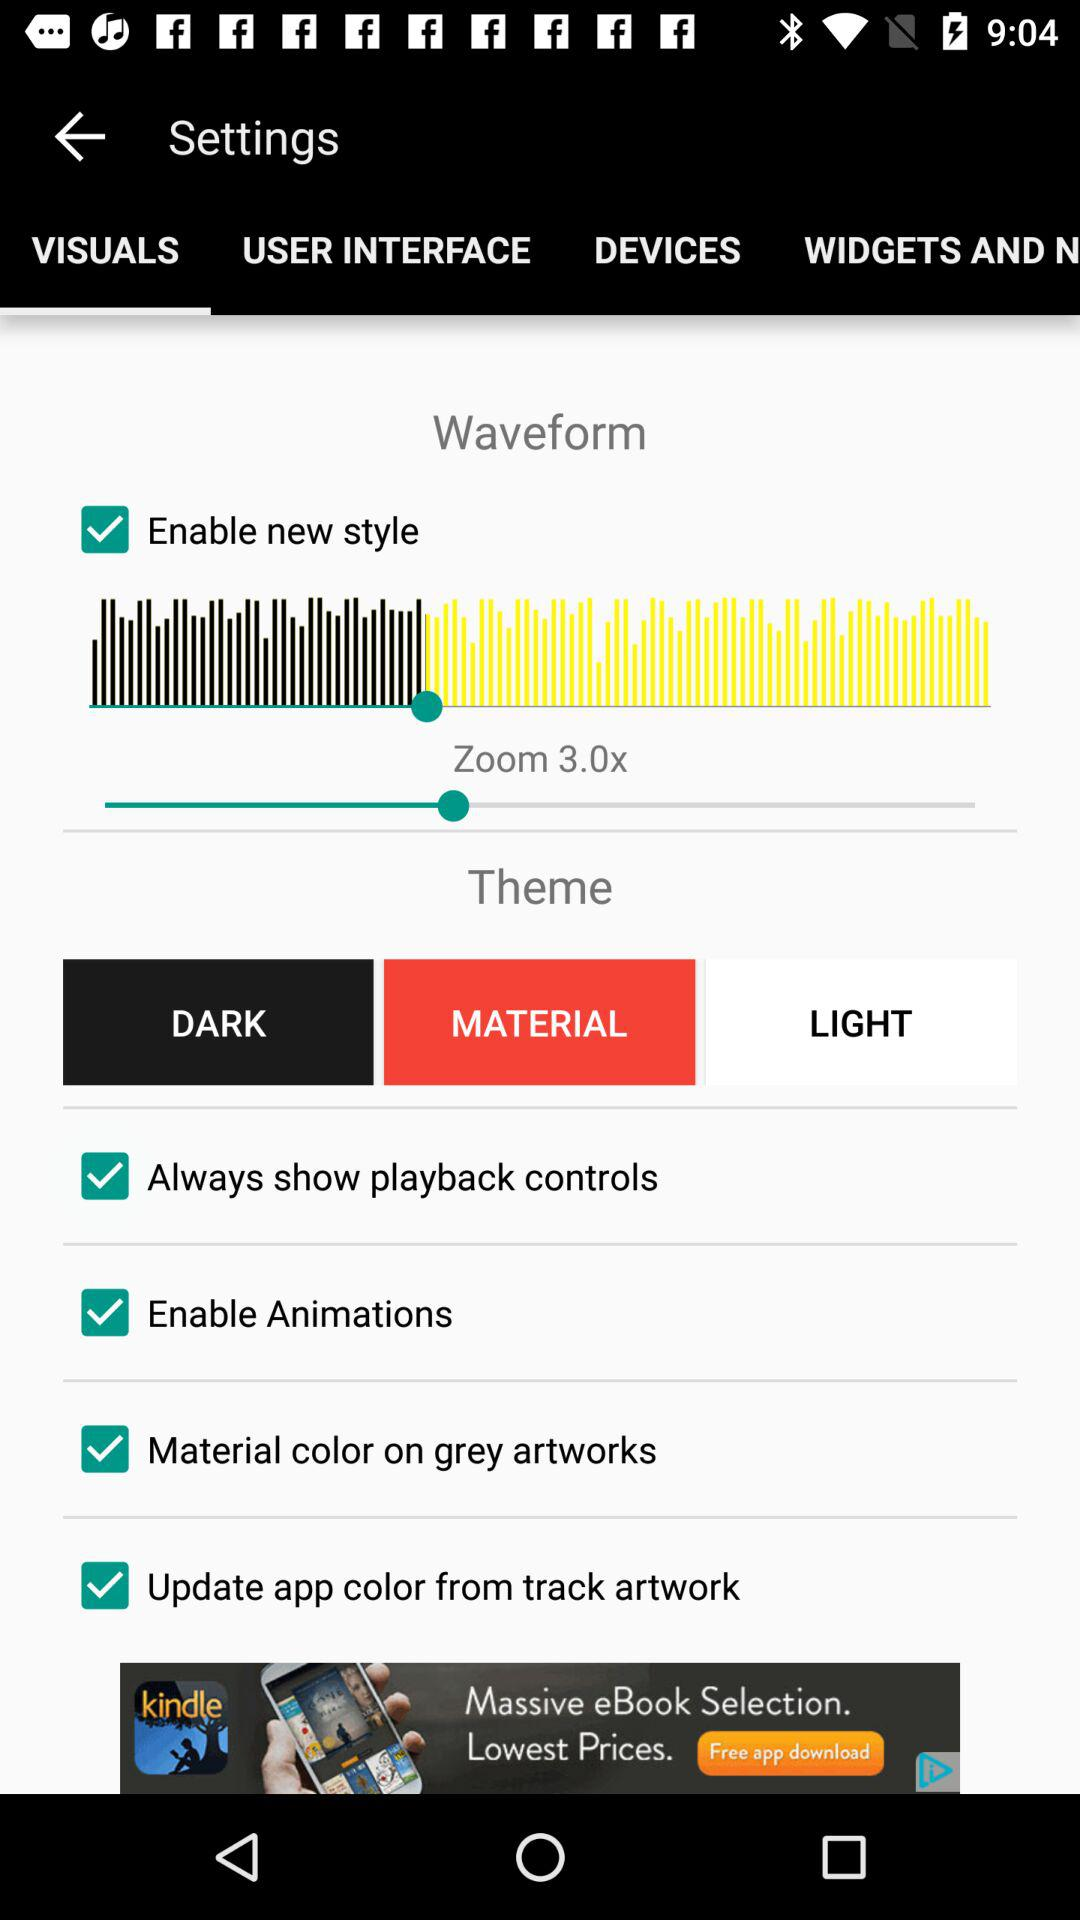What is the level of zoom? The level of zoom is 3.0x. 